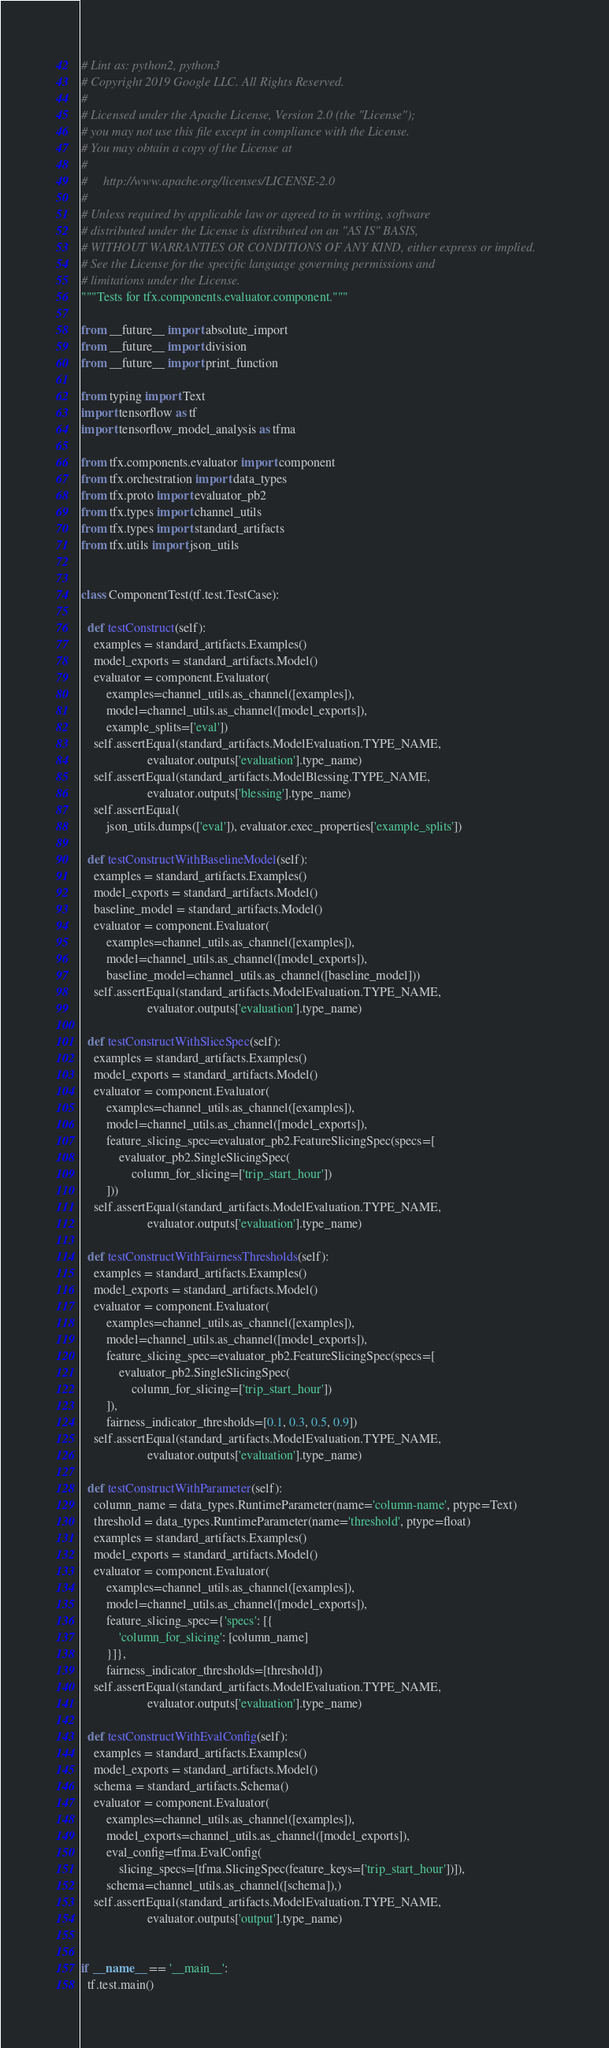Convert code to text. <code><loc_0><loc_0><loc_500><loc_500><_Python_># Lint as: python2, python3
# Copyright 2019 Google LLC. All Rights Reserved.
#
# Licensed under the Apache License, Version 2.0 (the "License");
# you may not use this file except in compliance with the License.
# You may obtain a copy of the License at
#
#     http://www.apache.org/licenses/LICENSE-2.0
#
# Unless required by applicable law or agreed to in writing, software
# distributed under the License is distributed on an "AS IS" BASIS,
# WITHOUT WARRANTIES OR CONDITIONS OF ANY KIND, either express or implied.
# See the License for the specific language governing permissions and
# limitations under the License.
"""Tests for tfx.components.evaluator.component."""

from __future__ import absolute_import
from __future__ import division
from __future__ import print_function

from typing import Text
import tensorflow as tf
import tensorflow_model_analysis as tfma

from tfx.components.evaluator import component
from tfx.orchestration import data_types
from tfx.proto import evaluator_pb2
from tfx.types import channel_utils
from tfx.types import standard_artifacts
from tfx.utils import json_utils


class ComponentTest(tf.test.TestCase):

  def testConstruct(self):
    examples = standard_artifacts.Examples()
    model_exports = standard_artifacts.Model()
    evaluator = component.Evaluator(
        examples=channel_utils.as_channel([examples]),
        model=channel_utils.as_channel([model_exports]),
        example_splits=['eval'])
    self.assertEqual(standard_artifacts.ModelEvaluation.TYPE_NAME,
                     evaluator.outputs['evaluation'].type_name)
    self.assertEqual(standard_artifacts.ModelBlessing.TYPE_NAME,
                     evaluator.outputs['blessing'].type_name)
    self.assertEqual(
        json_utils.dumps(['eval']), evaluator.exec_properties['example_splits'])

  def testConstructWithBaselineModel(self):
    examples = standard_artifacts.Examples()
    model_exports = standard_artifacts.Model()
    baseline_model = standard_artifacts.Model()
    evaluator = component.Evaluator(
        examples=channel_utils.as_channel([examples]),
        model=channel_utils.as_channel([model_exports]),
        baseline_model=channel_utils.as_channel([baseline_model]))
    self.assertEqual(standard_artifacts.ModelEvaluation.TYPE_NAME,
                     evaluator.outputs['evaluation'].type_name)

  def testConstructWithSliceSpec(self):
    examples = standard_artifacts.Examples()
    model_exports = standard_artifacts.Model()
    evaluator = component.Evaluator(
        examples=channel_utils.as_channel([examples]),
        model=channel_utils.as_channel([model_exports]),
        feature_slicing_spec=evaluator_pb2.FeatureSlicingSpec(specs=[
            evaluator_pb2.SingleSlicingSpec(
                column_for_slicing=['trip_start_hour'])
        ]))
    self.assertEqual(standard_artifacts.ModelEvaluation.TYPE_NAME,
                     evaluator.outputs['evaluation'].type_name)

  def testConstructWithFairnessThresholds(self):
    examples = standard_artifacts.Examples()
    model_exports = standard_artifacts.Model()
    evaluator = component.Evaluator(
        examples=channel_utils.as_channel([examples]),
        model=channel_utils.as_channel([model_exports]),
        feature_slicing_spec=evaluator_pb2.FeatureSlicingSpec(specs=[
            evaluator_pb2.SingleSlicingSpec(
                column_for_slicing=['trip_start_hour'])
        ]),
        fairness_indicator_thresholds=[0.1, 0.3, 0.5, 0.9])
    self.assertEqual(standard_artifacts.ModelEvaluation.TYPE_NAME,
                     evaluator.outputs['evaluation'].type_name)

  def testConstructWithParameter(self):
    column_name = data_types.RuntimeParameter(name='column-name', ptype=Text)
    threshold = data_types.RuntimeParameter(name='threshold', ptype=float)
    examples = standard_artifacts.Examples()
    model_exports = standard_artifacts.Model()
    evaluator = component.Evaluator(
        examples=channel_utils.as_channel([examples]),
        model=channel_utils.as_channel([model_exports]),
        feature_slicing_spec={'specs': [{
            'column_for_slicing': [column_name]
        }]},
        fairness_indicator_thresholds=[threshold])
    self.assertEqual(standard_artifacts.ModelEvaluation.TYPE_NAME,
                     evaluator.outputs['evaluation'].type_name)

  def testConstructWithEvalConfig(self):
    examples = standard_artifacts.Examples()
    model_exports = standard_artifacts.Model()
    schema = standard_artifacts.Schema()
    evaluator = component.Evaluator(
        examples=channel_utils.as_channel([examples]),
        model_exports=channel_utils.as_channel([model_exports]),
        eval_config=tfma.EvalConfig(
            slicing_specs=[tfma.SlicingSpec(feature_keys=['trip_start_hour'])]),
        schema=channel_utils.as_channel([schema]),)
    self.assertEqual(standard_artifacts.ModelEvaluation.TYPE_NAME,
                     evaluator.outputs['output'].type_name)


if __name__ == '__main__':
  tf.test.main()
</code> 